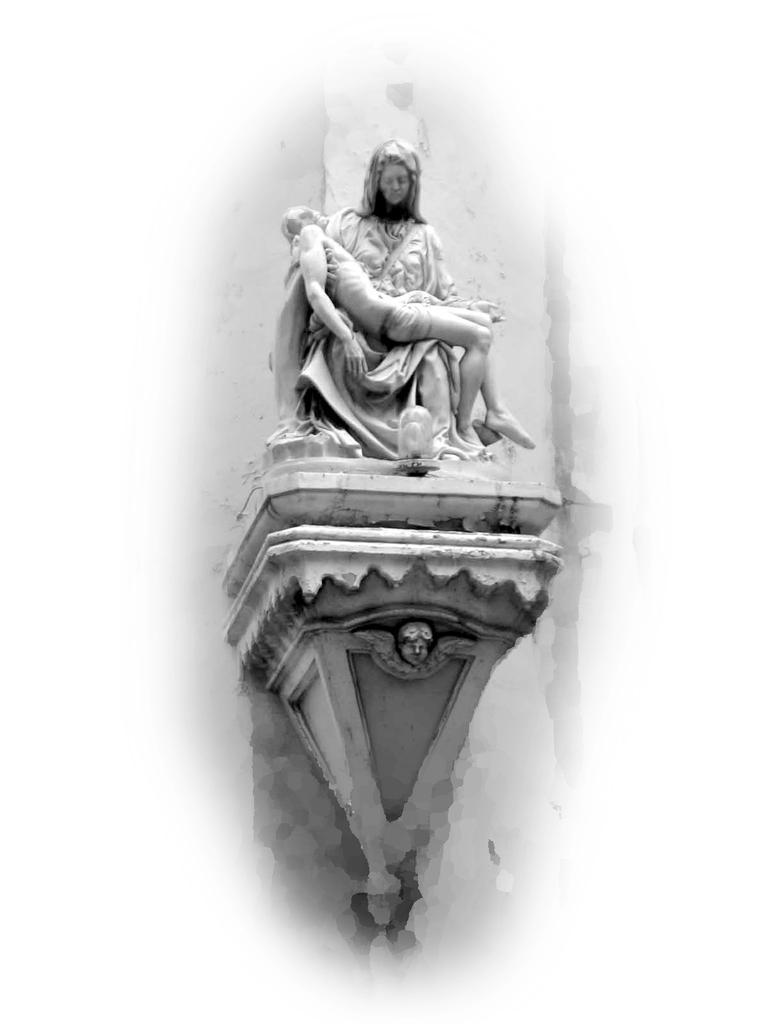Please provide a concise description of this image. There is a sculpture in the image. 